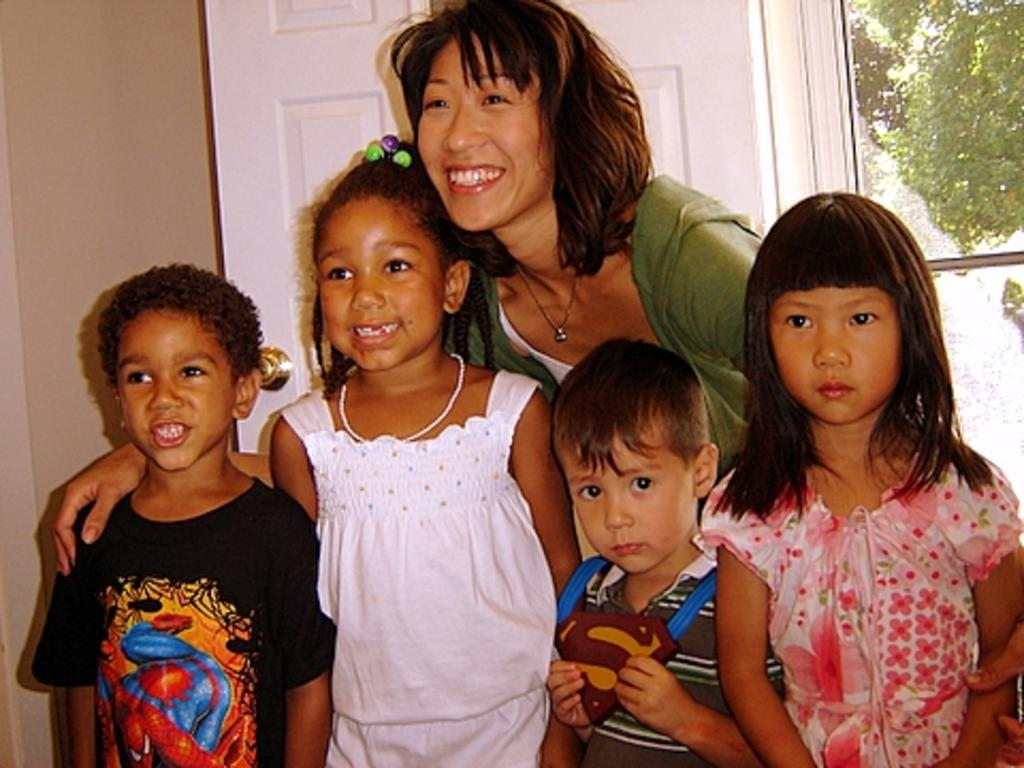Who is the main subject in the image? There is a woman in the image. How many children are present in the image? There are four children in the image. What is the emotional state of some of the children? Some of the children are smiling. What can be seen behind the woman? There is a door visible behind the woman. What type of vegetation is on the right side of the image? There are trees on the right side of the image. What type of system is being used to control the thunder in the image? There is no thunder or system present in the image; it features a woman and four children. How many clocks are visible in the image? There are no clocks visible in the image. 